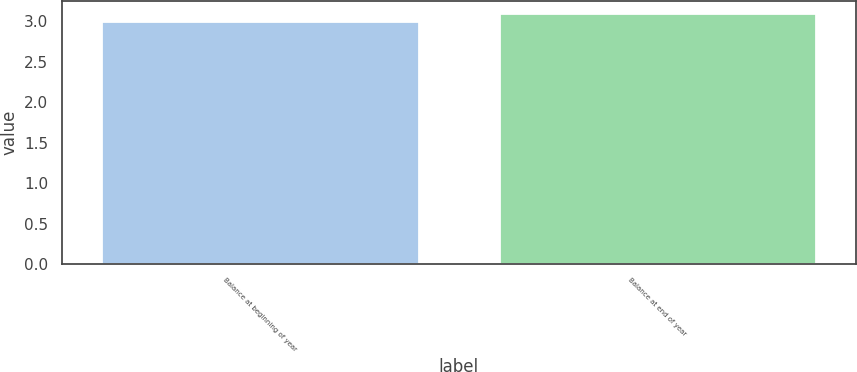<chart> <loc_0><loc_0><loc_500><loc_500><bar_chart><fcel>Balance at beginning of year<fcel>Balance at end of year<nl><fcel>3<fcel>3.1<nl></chart> 